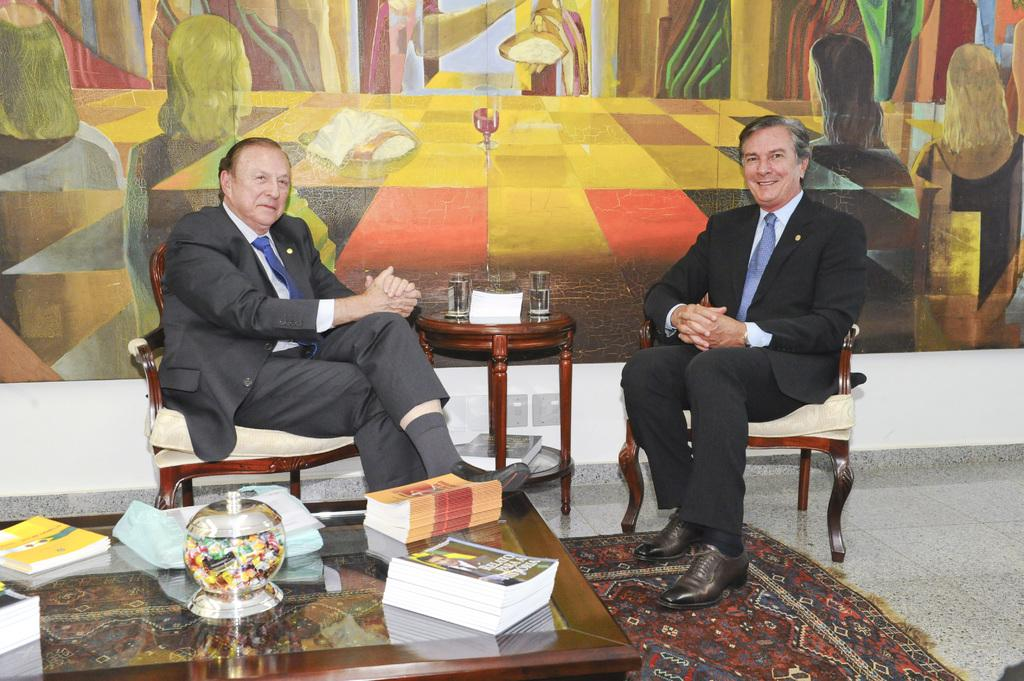What can be seen hanging in the image? There is a banner in the image. What are the two people in the image doing? The two people are sitting on chairs in the image. What is on the table in the image? There are books, a bowl, and two glasses on the table in the image. What might the people be using the banner for? The banner could be used for decoration or to convey a message. How many fish are swimming in the bowl on the table? There is no fish present in the image; the bowl on the table is empty. What type of birth is being celebrated in the image? There is no indication of a birth or celebration in the image. 